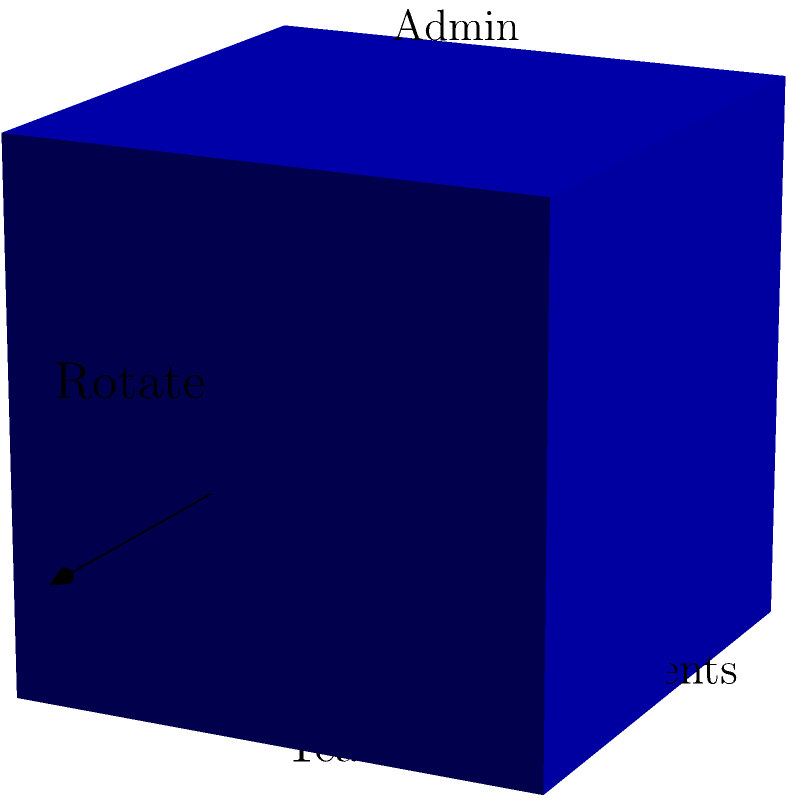In the context of developing ethical guidelines for an academic institution, the cube represents different stakeholder perspectives. If you mentally rotate the cube 90 degrees clockwise around the vertical axis, which stakeholder's perspective will be directly facing you? To solve this problem, we need to follow these steps:

1. Identify the current orientation of the cube:
   - Students are facing us (front face)
   - Teachers are on the right side
   - Parents are on the top face
   - Administrators are on the left side

2. Understand the rotation:
   - We need to rotate the cube 90 degrees clockwise around the vertical axis
   - This means the right face will become the front face

3. Visualize the rotation:
   - The face labeled "Teachers" will move to the front
   - The face labeled "Students" will move to the left
   - The face labeled "Administrators" will move to the back
   - The face labeled "Parents" will remain on top

4. Identify the new front-facing perspective:
   - After rotation, the "Teachers" perspective will be directly facing us

This mental rotation exercise demonstrates the importance of considering multiple stakeholder perspectives when developing educational policies and ethical guidelines. It emphasizes the need for policy makers to view issues from different angles to create comprehensive and balanced policies.
Answer: Teachers 